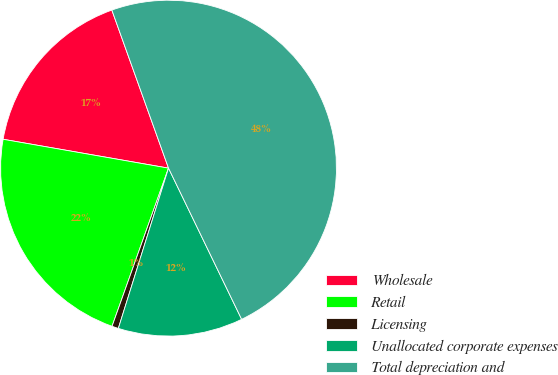<chart> <loc_0><loc_0><loc_500><loc_500><pie_chart><fcel>Wholesale<fcel>Retail<fcel>Licensing<fcel>Unallocated corporate expenses<fcel>Total depreciation and<nl><fcel>16.77%<fcel>22.29%<fcel>0.63%<fcel>12.0%<fcel>48.31%<nl></chart> 